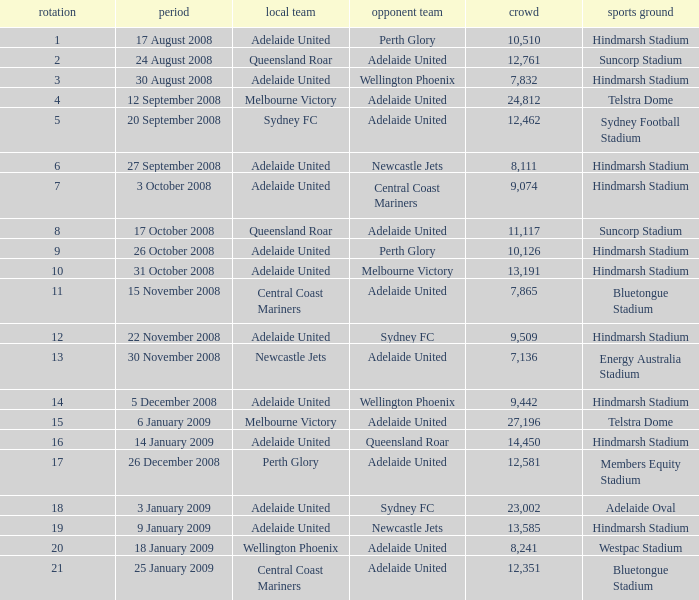What is the round when 11,117 people attended the game on 26 October 2008? 9.0. 